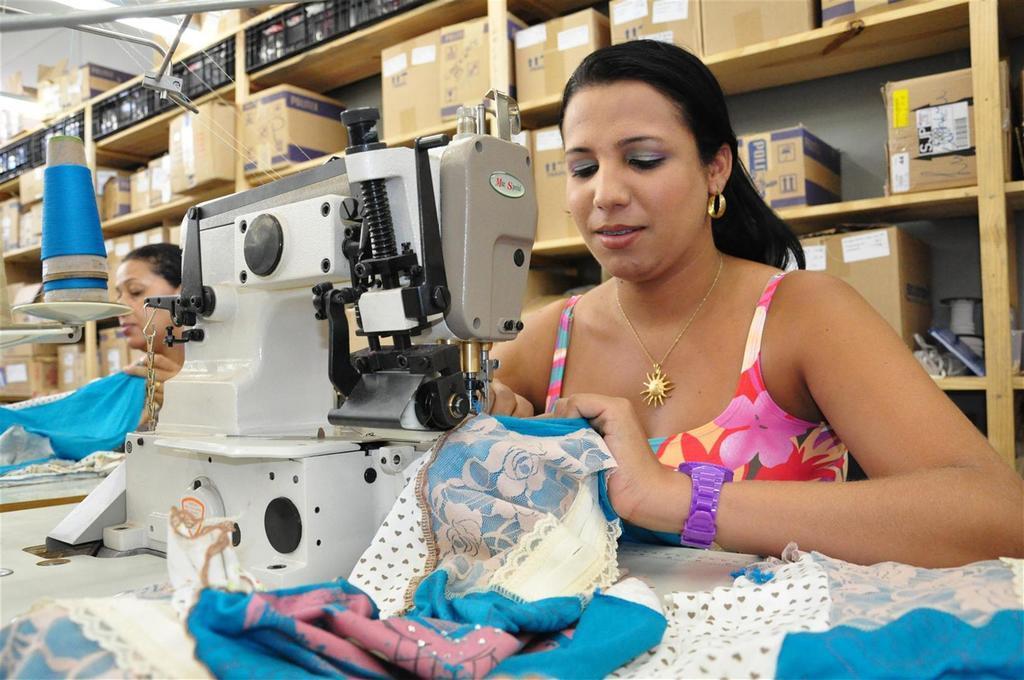In one or two sentences, can you explain what this image depicts? There are two women sitting. This looks like a sewing machine. These are the clothes. This looks like a thread, which is blue in color. I can see the cardboard boxes, which are arranged in the wooden rack. 